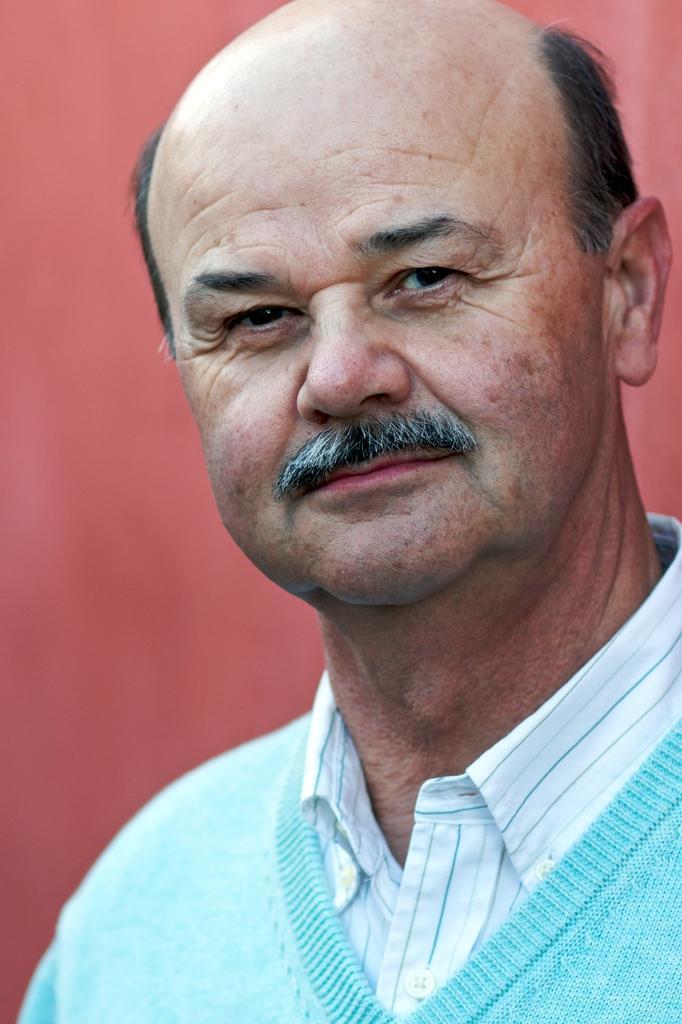In one or two sentences, can you explain what this image depicts? In this image we can see a man. 